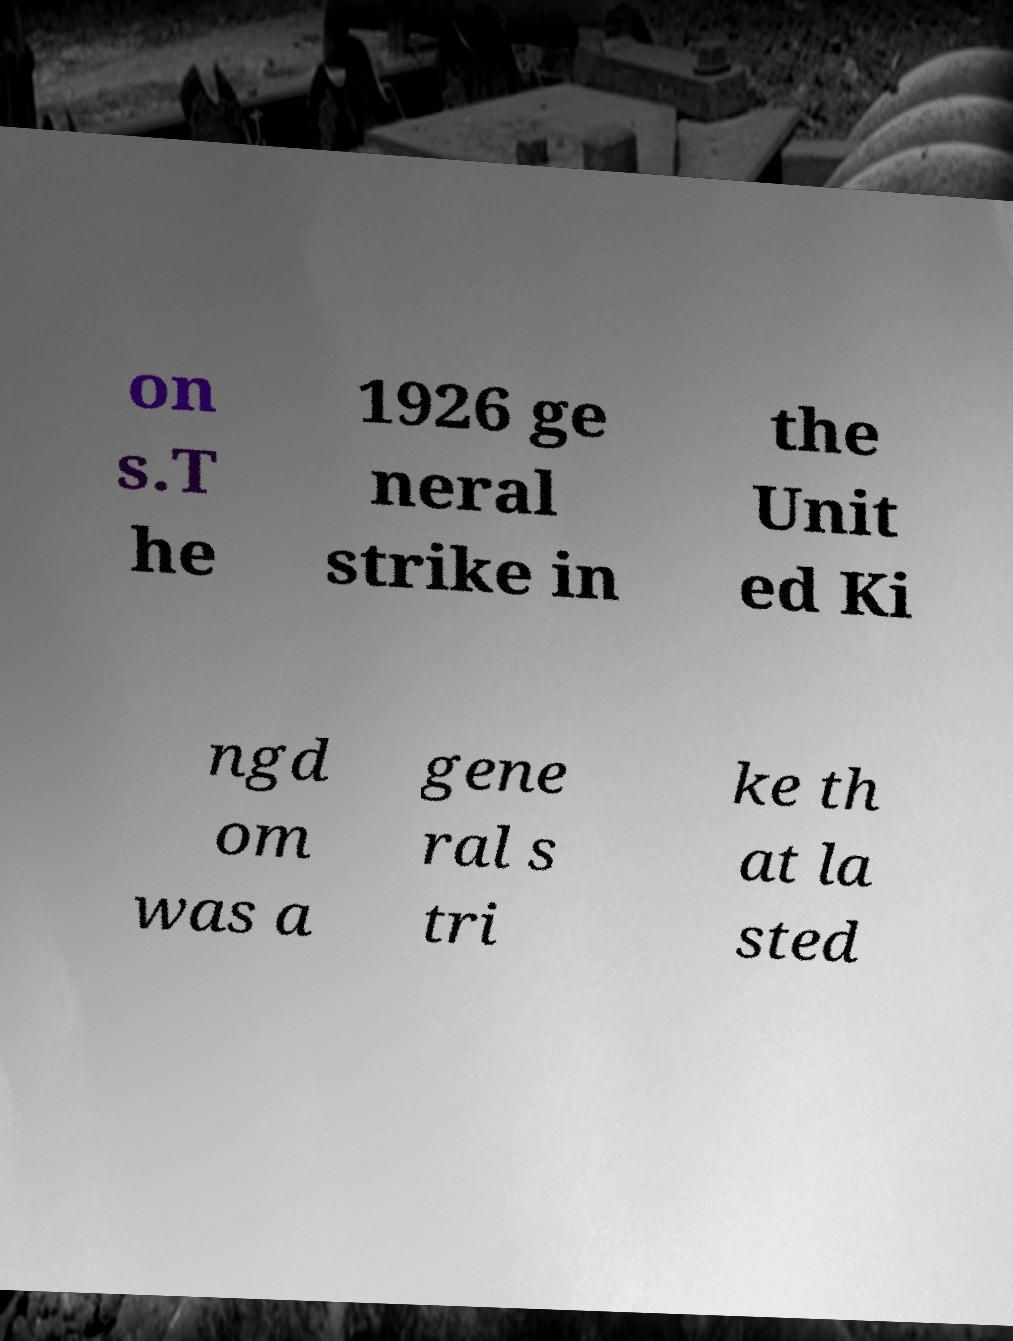Can you accurately transcribe the text from the provided image for me? on s.T he 1926 ge neral strike in the Unit ed Ki ngd om was a gene ral s tri ke th at la sted 